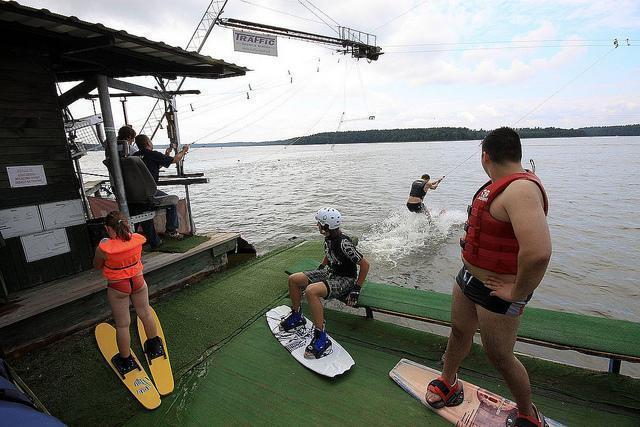What is the man wearing in red?
From the following four choices, select the correct answer to address the question.
Options: Scuba outfit, lifejacket, swimsuit, jeans. Lifejacket. 